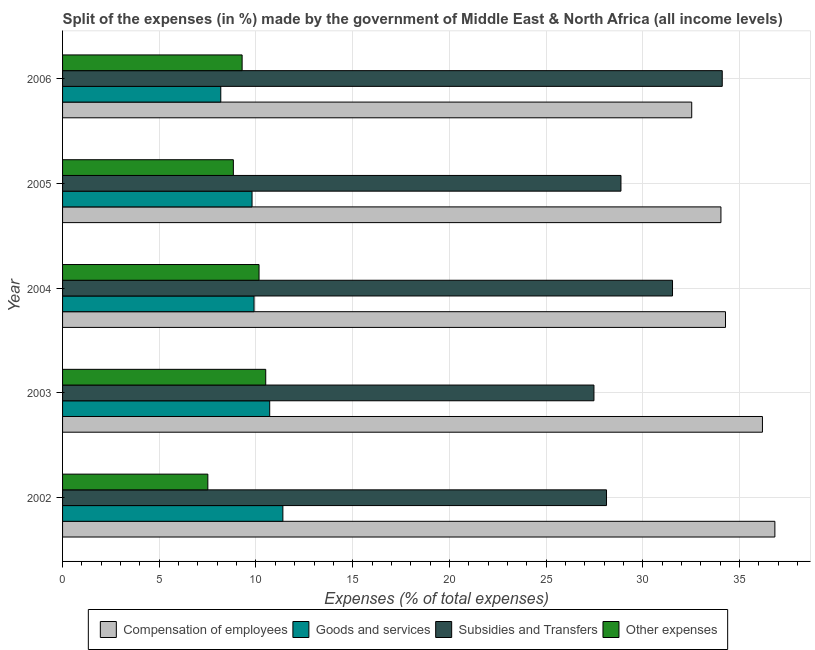How many different coloured bars are there?
Offer a terse response. 4. How many groups of bars are there?
Give a very brief answer. 5. Are the number of bars on each tick of the Y-axis equal?
Provide a succinct answer. Yes. How many bars are there on the 5th tick from the bottom?
Offer a terse response. 4. In how many cases, is the number of bars for a given year not equal to the number of legend labels?
Provide a short and direct response. 0. What is the percentage of amount spent on subsidies in 2006?
Provide a short and direct response. 34.11. Across all years, what is the maximum percentage of amount spent on goods and services?
Ensure brevity in your answer.  11.39. Across all years, what is the minimum percentage of amount spent on compensation of employees?
Make the answer very short. 32.53. In which year was the percentage of amount spent on other expenses maximum?
Give a very brief answer. 2003. In which year was the percentage of amount spent on compensation of employees minimum?
Offer a terse response. 2006. What is the total percentage of amount spent on goods and services in the graph?
Provide a short and direct response. 49.98. What is the difference between the percentage of amount spent on goods and services in 2002 and that in 2003?
Provide a short and direct response. 0.68. What is the difference between the percentage of amount spent on other expenses in 2003 and the percentage of amount spent on subsidies in 2005?
Your answer should be compact. -18.37. What is the average percentage of amount spent on goods and services per year?
Offer a terse response. 10. In the year 2006, what is the difference between the percentage of amount spent on compensation of employees and percentage of amount spent on goods and services?
Offer a very short reply. 24.35. What is the ratio of the percentage of amount spent on subsidies in 2002 to that in 2005?
Give a very brief answer. 0.97. Is the percentage of amount spent on other expenses in 2002 less than that in 2003?
Ensure brevity in your answer.  Yes. What is the difference between the highest and the second highest percentage of amount spent on subsidies?
Make the answer very short. 2.57. What is the difference between the highest and the lowest percentage of amount spent on subsidies?
Offer a terse response. 6.63. In how many years, is the percentage of amount spent on other expenses greater than the average percentage of amount spent on other expenses taken over all years?
Provide a short and direct response. 3. Is the sum of the percentage of amount spent on compensation of employees in 2005 and 2006 greater than the maximum percentage of amount spent on goods and services across all years?
Your answer should be compact. Yes. Is it the case that in every year, the sum of the percentage of amount spent on compensation of employees and percentage of amount spent on other expenses is greater than the sum of percentage of amount spent on subsidies and percentage of amount spent on goods and services?
Make the answer very short. No. What does the 1st bar from the top in 2004 represents?
Offer a terse response. Other expenses. What does the 2nd bar from the bottom in 2003 represents?
Your response must be concise. Goods and services. Is it the case that in every year, the sum of the percentage of amount spent on compensation of employees and percentage of amount spent on goods and services is greater than the percentage of amount spent on subsidies?
Give a very brief answer. Yes. How many bars are there?
Offer a very short reply. 20. Are all the bars in the graph horizontal?
Your answer should be very brief. Yes. Does the graph contain any zero values?
Provide a succinct answer. No. How many legend labels are there?
Offer a very short reply. 4. What is the title of the graph?
Offer a very short reply. Split of the expenses (in %) made by the government of Middle East & North Africa (all income levels). What is the label or title of the X-axis?
Make the answer very short. Expenses (% of total expenses). What is the label or title of the Y-axis?
Your response must be concise. Year. What is the Expenses (% of total expenses) of Compensation of employees in 2002?
Ensure brevity in your answer.  36.83. What is the Expenses (% of total expenses) of Goods and services in 2002?
Your answer should be very brief. 11.39. What is the Expenses (% of total expenses) in Subsidies and Transfers in 2002?
Make the answer very short. 28.12. What is the Expenses (% of total expenses) in Other expenses in 2002?
Give a very brief answer. 7.51. What is the Expenses (% of total expenses) of Compensation of employees in 2003?
Provide a succinct answer. 36.19. What is the Expenses (% of total expenses) of Goods and services in 2003?
Make the answer very short. 10.71. What is the Expenses (% of total expenses) of Subsidies and Transfers in 2003?
Provide a short and direct response. 27.47. What is the Expenses (% of total expenses) in Other expenses in 2003?
Offer a very short reply. 10.5. What is the Expenses (% of total expenses) of Compensation of employees in 2004?
Your response must be concise. 34.28. What is the Expenses (% of total expenses) of Goods and services in 2004?
Give a very brief answer. 9.9. What is the Expenses (% of total expenses) of Subsidies and Transfers in 2004?
Give a very brief answer. 31.54. What is the Expenses (% of total expenses) in Other expenses in 2004?
Your answer should be very brief. 10.16. What is the Expenses (% of total expenses) of Compensation of employees in 2005?
Provide a succinct answer. 34.04. What is the Expenses (% of total expenses) in Goods and services in 2005?
Your answer should be very brief. 9.8. What is the Expenses (% of total expenses) in Subsidies and Transfers in 2005?
Your response must be concise. 28.87. What is the Expenses (% of total expenses) in Other expenses in 2005?
Ensure brevity in your answer.  8.83. What is the Expenses (% of total expenses) in Compensation of employees in 2006?
Your response must be concise. 32.53. What is the Expenses (% of total expenses) of Goods and services in 2006?
Your answer should be very brief. 8.18. What is the Expenses (% of total expenses) in Subsidies and Transfers in 2006?
Offer a very short reply. 34.11. What is the Expenses (% of total expenses) of Other expenses in 2006?
Provide a short and direct response. 9.28. Across all years, what is the maximum Expenses (% of total expenses) in Compensation of employees?
Keep it short and to the point. 36.83. Across all years, what is the maximum Expenses (% of total expenses) of Goods and services?
Your answer should be very brief. 11.39. Across all years, what is the maximum Expenses (% of total expenses) in Subsidies and Transfers?
Give a very brief answer. 34.11. Across all years, what is the maximum Expenses (% of total expenses) in Other expenses?
Make the answer very short. 10.5. Across all years, what is the minimum Expenses (% of total expenses) of Compensation of employees?
Your response must be concise. 32.53. Across all years, what is the minimum Expenses (% of total expenses) of Goods and services?
Keep it short and to the point. 8.18. Across all years, what is the minimum Expenses (% of total expenses) of Subsidies and Transfers?
Provide a succinct answer. 27.47. Across all years, what is the minimum Expenses (% of total expenses) of Other expenses?
Keep it short and to the point. 7.51. What is the total Expenses (% of total expenses) of Compensation of employees in the graph?
Keep it short and to the point. 173.86. What is the total Expenses (% of total expenses) in Goods and services in the graph?
Keep it short and to the point. 49.98. What is the total Expenses (% of total expenses) in Subsidies and Transfers in the graph?
Provide a short and direct response. 150.11. What is the total Expenses (% of total expenses) of Other expenses in the graph?
Offer a terse response. 46.29. What is the difference between the Expenses (% of total expenses) in Compensation of employees in 2002 and that in 2003?
Your answer should be compact. 0.64. What is the difference between the Expenses (% of total expenses) of Goods and services in 2002 and that in 2003?
Keep it short and to the point. 0.68. What is the difference between the Expenses (% of total expenses) of Subsidies and Transfers in 2002 and that in 2003?
Provide a short and direct response. 0.65. What is the difference between the Expenses (% of total expenses) in Other expenses in 2002 and that in 2003?
Make the answer very short. -2.99. What is the difference between the Expenses (% of total expenses) in Compensation of employees in 2002 and that in 2004?
Provide a succinct answer. 2.55. What is the difference between the Expenses (% of total expenses) of Goods and services in 2002 and that in 2004?
Offer a terse response. 1.49. What is the difference between the Expenses (% of total expenses) in Subsidies and Transfers in 2002 and that in 2004?
Offer a very short reply. -3.41. What is the difference between the Expenses (% of total expenses) of Other expenses in 2002 and that in 2004?
Your answer should be compact. -2.65. What is the difference between the Expenses (% of total expenses) in Compensation of employees in 2002 and that in 2005?
Your response must be concise. 2.79. What is the difference between the Expenses (% of total expenses) in Goods and services in 2002 and that in 2005?
Your answer should be very brief. 1.59. What is the difference between the Expenses (% of total expenses) of Subsidies and Transfers in 2002 and that in 2005?
Provide a short and direct response. -0.75. What is the difference between the Expenses (% of total expenses) of Other expenses in 2002 and that in 2005?
Provide a succinct answer. -1.32. What is the difference between the Expenses (% of total expenses) in Compensation of employees in 2002 and that in 2006?
Ensure brevity in your answer.  4.3. What is the difference between the Expenses (% of total expenses) in Goods and services in 2002 and that in 2006?
Give a very brief answer. 3.21. What is the difference between the Expenses (% of total expenses) in Subsidies and Transfers in 2002 and that in 2006?
Provide a succinct answer. -5.98. What is the difference between the Expenses (% of total expenses) of Other expenses in 2002 and that in 2006?
Offer a very short reply. -1.77. What is the difference between the Expenses (% of total expenses) in Compensation of employees in 2003 and that in 2004?
Offer a terse response. 1.91. What is the difference between the Expenses (% of total expenses) in Goods and services in 2003 and that in 2004?
Offer a very short reply. 0.81. What is the difference between the Expenses (% of total expenses) of Subsidies and Transfers in 2003 and that in 2004?
Your answer should be compact. -4.06. What is the difference between the Expenses (% of total expenses) of Other expenses in 2003 and that in 2004?
Provide a succinct answer. 0.35. What is the difference between the Expenses (% of total expenses) in Compensation of employees in 2003 and that in 2005?
Provide a short and direct response. 2.15. What is the difference between the Expenses (% of total expenses) in Goods and services in 2003 and that in 2005?
Your answer should be compact. 0.91. What is the difference between the Expenses (% of total expenses) in Subsidies and Transfers in 2003 and that in 2005?
Give a very brief answer. -1.4. What is the difference between the Expenses (% of total expenses) in Other expenses in 2003 and that in 2005?
Your answer should be compact. 1.67. What is the difference between the Expenses (% of total expenses) of Compensation of employees in 2003 and that in 2006?
Your answer should be compact. 3.66. What is the difference between the Expenses (% of total expenses) in Goods and services in 2003 and that in 2006?
Your answer should be compact. 2.53. What is the difference between the Expenses (% of total expenses) of Subsidies and Transfers in 2003 and that in 2006?
Provide a succinct answer. -6.63. What is the difference between the Expenses (% of total expenses) of Other expenses in 2003 and that in 2006?
Ensure brevity in your answer.  1.22. What is the difference between the Expenses (% of total expenses) of Compensation of employees in 2004 and that in 2005?
Provide a succinct answer. 0.24. What is the difference between the Expenses (% of total expenses) in Goods and services in 2004 and that in 2005?
Keep it short and to the point. 0.1. What is the difference between the Expenses (% of total expenses) of Subsidies and Transfers in 2004 and that in 2005?
Your answer should be very brief. 2.67. What is the difference between the Expenses (% of total expenses) in Other expenses in 2004 and that in 2005?
Your answer should be compact. 1.33. What is the difference between the Expenses (% of total expenses) of Compensation of employees in 2004 and that in 2006?
Keep it short and to the point. 1.75. What is the difference between the Expenses (% of total expenses) in Goods and services in 2004 and that in 2006?
Your answer should be compact. 1.72. What is the difference between the Expenses (% of total expenses) of Subsidies and Transfers in 2004 and that in 2006?
Provide a succinct answer. -2.57. What is the difference between the Expenses (% of total expenses) in Other expenses in 2004 and that in 2006?
Provide a short and direct response. 0.87. What is the difference between the Expenses (% of total expenses) in Compensation of employees in 2005 and that in 2006?
Your answer should be very brief. 1.51. What is the difference between the Expenses (% of total expenses) of Goods and services in 2005 and that in 2006?
Give a very brief answer. 1.62. What is the difference between the Expenses (% of total expenses) in Subsidies and Transfers in 2005 and that in 2006?
Provide a succinct answer. -5.24. What is the difference between the Expenses (% of total expenses) of Other expenses in 2005 and that in 2006?
Your response must be concise. -0.45. What is the difference between the Expenses (% of total expenses) in Compensation of employees in 2002 and the Expenses (% of total expenses) in Goods and services in 2003?
Offer a terse response. 26.12. What is the difference between the Expenses (% of total expenses) of Compensation of employees in 2002 and the Expenses (% of total expenses) of Subsidies and Transfers in 2003?
Your answer should be very brief. 9.35. What is the difference between the Expenses (% of total expenses) in Compensation of employees in 2002 and the Expenses (% of total expenses) in Other expenses in 2003?
Give a very brief answer. 26.32. What is the difference between the Expenses (% of total expenses) of Goods and services in 2002 and the Expenses (% of total expenses) of Subsidies and Transfers in 2003?
Your response must be concise. -16.08. What is the difference between the Expenses (% of total expenses) in Goods and services in 2002 and the Expenses (% of total expenses) in Other expenses in 2003?
Give a very brief answer. 0.89. What is the difference between the Expenses (% of total expenses) in Subsidies and Transfers in 2002 and the Expenses (% of total expenses) in Other expenses in 2003?
Your answer should be compact. 17.62. What is the difference between the Expenses (% of total expenses) in Compensation of employees in 2002 and the Expenses (% of total expenses) in Goods and services in 2004?
Offer a terse response. 26.93. What is the difference between the Expenses (% of total expenses) of Compensation of employees in 2002 and the Expenses (% of total expenses) of Subsidies and Transfers in 2004?
Your answer should be compact. 5.29. What is the difference between the Expenses (% of total expenses) in Compensation of employees in 2002 and the Expenses (% of total expenses) in Other expenses in 2004?
Your response must be concise. 26.67. What is the difference between the Expenses (% of total expenses) of Goods and services in 2002 and the Expenses (% of total expenses) of Subsidies and Transfers in 2004?
Your answer should be compact. -20.15. What is the difference between the Expenses (% of total expenses) of Goods and services in 2002 and the Expenses (% of total expenses) of Other expenses in 2004?
Your response must be concise. 1.23. What is the difference between the Expenses (% of total expenses) of Subsidies and Transfers in 2002 and the Expenses (% of total expenses) of Other expenses in 2004?
Offer a terse response. 17.97. What is the difference between the Expenses (% of total expenses) of Compensation of employees in 2002 and the Expenses (% of total expenses) of Goods and services in 2005?
Your answer should be compact. 27.03. What is the difference between the Expenses (% of total expenses) of Compensation of employees in 2002 and the Expenses (% of total expenses) of Subsidies and Transfers in 2005?
Make the answer very short. 7.96. What is the difference between the Expenses (% of total expenses) in Compensation of employees in 2002 and the Expenses (% of total expenses) in Other expenses in 2005?
Offer a terse response. 28. What is the difference between the Expenses (% of total expenses) of Goods and services in 2002 and the Expenses (% of total expenses) of Subsidies and Transfers in 2005?
Your answer should be compact. -17.48. What is the difference between the Expenses (% of total expenses) of Goods and services in 2002 and the Expenses (% of total expenses) of Other expenses in 2005?
Provide a short and direct response. 2.56. What is the difference between the Expenses (% of total expenses) of Subsidies and Transfers in 2002 and the Expenses (% of total expenses) of Other expenses in 2005?
Your answer should be compact. 19.29. What is the difference between the Expenses (% of total expenses) in Compensation of employees in 2002 and the Expenses (% of total expenses) in Goods and services in 2006?
Give a very brief answer. 28.65. What is the difference between the Expenses (% of total expenses) of Compensation of employees in 2002 and the Expenses (% of total expenses) of Subsidies and Transfers in 2006?
Ensure brevity in your answer.  2.72. What is the difference between the Expenses (% of total expenses) of Compensation of employees in 2002 and the Expenses (% of total expenses) of Other expenses in 2006?
Your answer should be compact. 27.55. What is the difference between the Expenses (% of total expenses) of Goods and services in 2002 and the Expenses (% of total expenses) of Subsidies and Transfers in 2006?
Your answer should be very brief. -22.72. What is the difference between the Expenses (% of total expenses) in Goods and services in 2002 and the Expenses (% of total expenses) in Other expenses in 2006?
Your answer should be very brief. 2.11. What is the difference between the Expenses (% of total expenses) of Subsidies and Transfers in 2002 and the Expenses (% of total expenses) of Other expenses in 2006?
Offer a very short reply. 18.84. What is the difference between the Expenses (% of total expenses) of Compensation of employees in 2003 and the Expenses (% of total expenses) of Goods and services in 2004?
Keep it short and to the point. 26.29. What is the difference between the Expenses (% of total expenses) in Compensation of employees in 2003 and the Expenses (% of total expenses) in Subsidies and Transfers in 2004?
Offer a very short reply. 4.65. What is the difference between the Expenses (% of total expenses) of Compensation of employees in 2003 and the Expenses (% of total expenses) of Other expenses in 2004?
Offer a very short reply. 26.03. What is the difference between the Expenses (% of total expenses) of Goods and services in 2003 and the Expenses (% of total expenses) of Subsidies and Transfers in 2004?
Provide a short and direct response. -20.83. What is the difference between the Expenses (% of total expenses) of Goods and services in 2003 and the Expenses (% of total expenses) of Other expenses in 2004?
Make the answer very short. 0.55. What is the difference between the Expenses (% of total expenses) of Subsidies and Transfers in 2003 and the Expenses (% of total expenses) of Other expenses in 2004?
Give a very brief answer. 17.32. What is the difference between the Expenses (% of total expenses) of Compensation of employees in 2003 and the Expenses (% of total expenses) of Goods and services in 2005?
Your response must be concise. 26.39. What is the difference between the Expenses (% of total expenses) in Compensation of employees in 2003 and the Expenses (% of total expenses) in Subsidies and Transfers in 2005?
Give a very brief answer. 7.32. What is the difference between the Expenses (% of total expenses) of Compensation of employees in 2003 and the Expenses (% of total expenses) of Other expenses in 2005?
Give a very brief answer. 27.36. What is the difference between the Expenses (% of total expenses) of Goods and services in 2003 and the Expenses (% of total expenses) of Subsidies and Transfers in 2005?
Your answer should be compact. -18.16. What is the difference between the Expenses (% of total expenses) in Goods and services in 2003 and the Expenses (% of total expenses) in Other expenses in 2005?
Give a very brief answer. 1.88. What is the difference between the Expenses (% of total expenses) of Subsidies and Transfers in 2003 and the Expenses (% of total expenses) of Other expenses in 2005?
Make the answer very short. 18.64. What is the difference between the Expenses (% of total expenses) of Compensation of employees in 2003 and the Expenses (% of total expenses) of Goods and services in 2006?
Your response must be concise. 28.01. What is the difference between the Expenses (% of total expenses) in Compensation of employees in 2003 and the Expenses (% of total expenses) in Subsidies and Transfers in 2006?
Provide a succinct answer. 2.08. What is the difference between the Expenses (% of total expenses) in Compensation of employees in 2003 and the Expenses (% of total expenses) in Other expenses in 2006?
Ensure brevity in your answer.  26.9. What is the difference between the Expenses (% of total expenses) in Goods and services in 2003 and the Expenses (% of total expenses) in Subsidies and Transfers in 2006?
Keep it short and to the point. -23.4. What is the difference between the Expenses (% of total expenses) of Goods and services in 2003 and the Expenses (% of total expenses) of Other expenses in 2006?
Keep it short and to the point. 1.43. What is the difference between the Expenses (% of total expenses) in Subsidies and Transfers in 2003 and the Expenses (% of total expenses) in Other expenses in 2006?
Ensure brevity in your answer.  18.19. What is the difference between the Expenses (% of total expenses) in Compensation of employees in 2004 and the Expenses (% of total expenses) in Goods and services in 2005?
Ensure brevity in your answer.  24.48. What is the difference between the Expenses (% of total expenses) in Compensation of employees in 2004 and the Expenses (% of total expenses) in Subsidies and Transfers in 2005?
Your answer should be very brief. 5.4. What is the difference between the Expenses (% of total expenses) of Compensation of employees in 2004 and the Expenses (% of total expenses) of Other expenses in 2005?
Give a very brief answer. 25.45. What is the difference between the Expenses (% of total expenses) of Goods and services in 2004 and the Expenses (% of total expenses) of Subsidies and Transfers in 2005?
Your answer should be very brief. -18.97. What is the difference between the Expenses (% of total expenses) in Goods and services in 2004 and the Expenses (% of total expenses) in Other expenses in 2005?
Keep it short and to the point. 1.07. What is the difference between the Expenses (% of total expenses) of Subsidies and Transfers in 2004 and the Expenses (% of total expenses) of Other expenses in 2005?
Make the answer very short. 22.71. What is the difference between the Expenses (% of total expenses) of Compensation of employees in 2004 and the Expenses (% of total expenses) of Goods and services in 2006?
Provide a short and direct response. 26.1. What is the difference between the Expenses (% of total expenses) of Compensation of employees in 2004 and the Expenses (% of total expenses) of Subsidies and Transfers in 2006?
Your response must be concise. 0.17. What is the difference between the Expenses (% of total expenses) in Compensation of employees in 2004 and the Expenses (% of total expenses) in Other expenses in 2006?
Make the answer very short. 24.99. What is the difference between the Expenses (% of total expenses) of Goods and services in 2004 and the Expenses (% of total expenses) of Subsidies and Transfers in 2006?
Your answer should be compact. -24.21. What is the difference between the Expenses (% of total expenses) of Goods and services in 2004 and the Expenses (% of total expenses) of Other expenses in 2006?
Your response must be concise. 0.62. What is the difference between the Expenses (% of total expenses) of Subsidies and Transfers in 2004 and the Expenses (% of total expenses) of Other expenses in 2006?
Keep it short and to the point. 22.25. What is the difference between the Expenses (% of total expenses) of Compensation of employees in 2005 and the Expenses (% of total expenses) of Goods and services in 2006?
Your answer should be compact. 25.86. What is the difference between the Expenses (% of total expenses) in Compensation of employees in 2005 and the Expenses (% of total expenses) in Subsidies and Transfers in 2006?
Provide a succinct answer. -0.07. What is the difference between the Expenses (% of total expenses) of Compensation of employees in 2005 and the Expenses (% of total expenses) of Other expenses in 2006?
Give a very brief answer. 24.76. What is the difference between the Expenses (% of total expenses) in Goods and services in 2005 and the Expenses (% of total expenses) in Subsidies and Transfers in 2006?
Provide a short and direct response. -24.31. What is the difference between the Expenses (% of total expenses) of Goods and services in 2005 and the Expenses (% of total expenses) of Other expenses in 2006?
Keep it short and to the point. 0.51. What is the difference between the Expenses (% of total expenses) in Subsidies and Transfers in 2005 and the Expenses (% of total expenses) in Other expenses in 2006?
Ensure brevity in your answer.  19.59. What is the average Expenses (% of total expenses) in Compensation of employees per year?
Your answer should be compact. 34.77. What is the average Expenses (% of total expenses) in Goods and services per year?
Your answer should be very brief. 10. What is the average Expenses (% of total expenses) in Subsidies and Transfers per year?
Your response must be concise. 30.02. What is the average Expenses (% of total expenses) in Other expenses per year?
Offer a terse response. 9.26. In the year 2002, what is the difference between the Expenses (% of total expenses) of Compensation of employees and Expenses (% of total expenses) of Goods and services?
Offer a very short reply. 25.44. In the year 2002, what is the difference between the Expenses (% of total expenses) in Compensation of employees and Expenses (% of total expenses) in Subsidies and Transfers?
Provide a succinct answer. 8.71. In the year 2002, what is the difference between the Expenses (% of total expenses) in Compensation of employees and Expenses (% of total expenses) in Other expenses?
Ensure brevity in your answer.  29.32. In the year 2002, what is the difference between the Expenses (% of total expenses) of Goods and services and Expenses (% of total expenses) of Subsidies and Transfers?
Make the answer very short. -16.73. In the year 2002, what is the difference between the Expenses (% of total expenses) of Goods and services and Expenses (% of total expenses) of Other expenses?
Make the answer very short. 3.88. In the year 2002, what is the difference between the Expenses (% of total expenses) of Subsidies and Transfers and Expenses (% of total expenses) of Other expenses?
Provide a succinct answer. 20.61. In the year 2003, what is the difference between the Expenses (% of total expenses) of Compensation of employees and Expenses (% of total expenses) of Goods and services?
Your answer should be compact. 25.48. In the year 2003, what is the difference between the Expenses (% of total expenses) of Compensation of employees and Expenses (% of total expenses) of Subsidies and Transfers?
Your response must be concise. 8.71. In the year 2003, what is the difference between the Expenses (% of total expenses) in Compensation of employees and Expenses (% of total expenses) in Other expenses?
Your answer should be very brief. 25.68. In the year 2003, what is the difference between the Expenses (% of total expenses) of Goods and services and Expenses (% of total expenses) of Subsidies and Transfers?
Provide a short and direct response. -16.76. In the year 2003, what is the difference between the Expenses (% of total expenses) in Goods and services and Expenses (% of total expenses) in Other expenses?
Keep it short and to the point. 0.21. In the year 2003, what is the difference between the Expenses (% of total expenses) of Subsidies and Transfers and Expenses (% of total expenses) of Other expenses?
Offer a very short reply. 16.97. In the year 2004, what is the difference between the Expenses (% of total expenses) in Compensation of employees and Expenses (% of total expenses) in Goods and services?
Your response must be concise. 24.38. In the year 2004, what is the difference between the Expenses (% of total expenses) of Compensation of employees and Expenses (% of total expenses) of Subsidies and Transfers?
Your answer should be compact. 2.74. In the year 2004, what is the difference between the Expenses (% of total expenses) of Compensation of employees and Expenses (% of total expenses) of Other expenses?
Keep it short and to the point. 24.12. In the year 2004, what is the difference between the Expenses (% of total expenses) of Goods and services and Expenses (% of total expenses) of Subsidies and Transfers?
Provide a short and direct response. -21.64. In the year 2004, what is the difference between the Expenses (% of total expenses) in Goods and services and Expenses (% of total expenses) in Other expenses?
Your response must be concise. -0.26. In the year 2004, what is the difference between the Expenses (% of total expenses) of Subsidies and Transfers and Expenses (% of total expenses) of Other expenses?
Provide a short and direct response. 21.38. In the year 2005, what is the difference between the Expenses (% of total expenses) of Compensation of employees and Expenses (% of total expenses) of Goods and services?
Offer a very short reply. 24.24. In the year 2005, what is the difference between the Expenses (% of total expenses) in Compensation of employees and Expenses (% of total expenses) in Subsidies and Transfers?
Your answer should be compact. 5.17. In the year 2005, what is the difference between the Expenses (% of total expenses) in Compensation of employees and Expenses (% of total expenses) in Other expenses?
Ensure brevity in your answer.  25.21. In the year 2005, what is the difference between the Expenses (% of total expenses) in Goods and services and Expenses (% of total expenses) in Subsidies and Transfers?
Give a very brief answer. -19.07. In the year 2005, what is the difference between the Expenses (% of total expenses) of Goods and services and Expenses (% of total expenses) of Other expenses?
Ensure brevity in your answer.  0.97. In the year 2005, what is the difference between the Expenses (% of total expenses) in Subsidies and Transfers and Expenses (% of total expenses) in Other expenses?
Give a very brief answer. 20.04. In the year 2006, what is the difference between the Expenses (% of total expenses) of Compensation of employees and Expenses (% of total expenses) of Goods and services?
Ensure brevity in your answer.  24.35. In the year 2006, what is the difference between the Expenses (% of total expenses) of Compensation of employees and Expenses (% of total expenses) of Subsidies and Transfers?
Your response must be concise. -1.58. In the year 2006, what is the difference between the Expenses (% of total expenses) in Compensation of employees and Expenses (% of total expenses) in Other expenses?
Provide a succinct answer. 23.25. In the year 2006, what is the difference between the Expenses (% of total expenses) of Goods and services and Expenses (% of total expenses) of Subsidies and Transfers?
Provide a succinct answer. -25.93. In the year 2006, what is the difference between the Expenses (% of total expenses) of Goods and services and Expenses (% of total expenses) of Other expenses?
Ensure brevity in your answer.  -1.1. In the year 2006, what is the difference between the Expenses (% of total expenses) of Subsidies and Transfers and Expenses (% of total expenses) of Other expenses?
Provide a short and direct response. 24.82. What is the ratio of the Expenses (% of total expenses) of Compensation of employees in 2002 to that in 2003?
Offer a very short reply. 1.02. What is the ratio of the Expenses (% of total expenses) of Goods and services in 2002 to that in 2003?
Provide a succinct answer. 1.06. What is the ratio of the Expenses (% of total expenses) of Subsidies and Transfers in 2002 to that in 2003?
Your response must be concise. 1.02. What is the ratio of the Expenses (% of total expenses) of Other expenses in 2002 to that in 2003?
Make the answer very short. 0.72. What is the ratio of the Expenses (% of total expenses) of Compensation of employees in 2002 to that in 2004?
Your response must be concise. 1.07. What is the ratio of the Expenses (% of total expenses) of Goods and services in 2002 to that in 2004?
Offer a terse response. 1.15. What is the ratio of the Expenses (% of total expenses) in Subsidies and Transfers in 2002 to that in 2004?
Give a very brief answer. 0.89. What is the ratio of the Expenses (% of total expenses) of Other expenses in 2002 to that in 2004?
Make the answer very short. 0.74. What is the ratio of the Expenses (% of total expenses) of Compensation of employees in 2002 to that in 2005?
Your response must be concise. 1.08. What is the ratio of the Expenses (% of total expenses) of Goods and services in 2002 to that in 2005?
Provide a succinct answer. 1.16. What is the ratio of the Expenses (% of total expenses) of Subsidies and Transfers in 2002 to that in 2005?
Offer a very short reply. 0.97. What is the ratio of the Expenses (% of total expenses) in Other expenses in 2002 to that in 2005?
Offer a very short reply. 0.85. What is the ratio of the Expenses (% of total expenses) of Compensation of employees in 2002 to that in 2006?
Give a very brief answer. 1.13. What is the ratio of the Expenses (% of total expenses) of Goods and services in 2002 to that in 2006?
Keep it short and to the point. 1.39. What is the ratio of the Expenses (% of total expenses) of Subsidies and Transfers in 2002 to that in 2006?
Your answer should be compact. 0.82. What is the ratio of the Expenses (% of total expenses) in Other expenses in 2002 to that in 2006?
Offer a terse response. 0.81. What is the ratio of the Expenses (% of total expenses) of Compensation of employees in 2003 to that in 2004?
Provide a succinct answer. 1.06. What is the ratio of the Expenses (% of total expenses) in Goods and services in 2003 to that in 2004?
Make the answer very short. 1.08. What is the ratio of the Expenses (% of total expenses) of Subsidies and Transfers in 2003 to that in 2004?
Your answer should be very brief. 0.87. What is the ratio of the Expenses (% of total expenses) of Other expenses in 2003 to that in 2004?
Your response must be concise. 1.03. What is the ratio of the Expenses (% of total expenses) of Compensation of employees in 2003 to that in 2005?
Offer a very short reply. 1.06. What is the ratio of the Expenses (% of total expenses) of Goods and services in 2003 to that in 2005?
Give a very brief answer. 1.09. What is the ratio of the Expenses (% of total expenses) in Subsidies and Transfers in 2003 to that in 2005?
Your answer should be compact. 0.95. What is the ratio of the Expenses (% of total expenses) of Other expenses in 2003 to that in 2005?
Your answer should be compact. 1.19. What is the ratio of the Expenses (% of total expenses) of Compensation of employees in 2003 to that in 2006?
Your response must be concise. 1.11. What is the ratio of the Expenses (% of total expenses) of Goods and services in 2003 to that in 2006?
Provide a short and direct response. 1.31. What is the ratio of the Expenses (% of total expenses) of Subsidies and Transfers in 2003 to that in 2006?
Provide a succinct answer. 0.81. What is the ratio of the Expenses (% of total expenses) of Other expenses in 2003 to that in 2006?
Offer a very short reply. 1.13. What is the ratio of the Expenses (% of total expenses) of Goods and services in 2004 to that in 2005?
Your answer should be very brief. 1.01. What is the ratio of the Expenses (% of total expenses) in Subsidies and Transfers in 2004 to that in 2005?
Offer a very short reply. 1.09. What is the ratio of the Expenses (% of total expenses) in Other expenses in 2004 to that in 2005?
Your response must be concise. 1.15. What is the ratio of the Expenses (% of total expenses) of Compensation of employees in 2004 to that in 2006?
Offer a terse response. 1.05. What is the ratio of the Expenses (% of total expenses) of Goods and services in 2004 to that in 2006?
Offer a very short reply. 1.21. What is the ratio of the Expenses (% of total expenses) in Subsidies and Transfers in 2004 to that in 2006?
Your answer should be compact. 0.92. What is the ratio of the Expenses (% of total expenses) in Other expenses in 2004 to that in 2006?
Provide a succinct answer. 1.09. What is the ratio of the Expenses (% of total expenses) of Compensation of employees in 2005 to that in 2006?
Keep it short and to the point. 1.05. What is the ratio of the Expenses (% of total expenses) of Goods and services in 2005 to that in 2006?
Offer a terse response. 1.2. What is the ratio of the Expenses (% of total expenses) in Subsidies and Transfers in 2005 to that in 2006?
Provide a short and direct response. 0.85. What is the ratio of the Expenses (% of total expenses) of Other expenses in 2005 to that in 2006?
Offer a very short reply. 0.95. What is the difference between the highest and the second highest Expenses (% of total expenses) of Compensation of employees?
Ensure brevity in your answer.  0.64. What is the difference between the highest and the second highest Expenses (% of total expenses) of Goods and services?
Ensure brevity in your answer.  0.68. What is the difference between the highest and the second highest Expenses (% of total expenses) in Subsidies and Transfers?
Ensure brevity in your answer.  2.57. What is the difference between the highest and the second highest Expenses (% of total expenses) of Other expenses?
Your answer should be compact. 0.35. What is the difference between the highest and the lowest Expenses (% of total expenses) of Compensation of employees?
Make the answer very short. 4.3. What is the difference between the highest and the lowest Expenses (% of total expenses) in Goods and services?
Provide a succinct answer. 3.21. What is the difference between the highest and the lowest Expenses (% of total expenses) in Subsidies and Transfers?
Provide a succinct answer. 6.63. What is the difference between the highest and the lowest Expenses (% of total expenses) of Other expenses?
Provide a succinct answer. 2.99. 